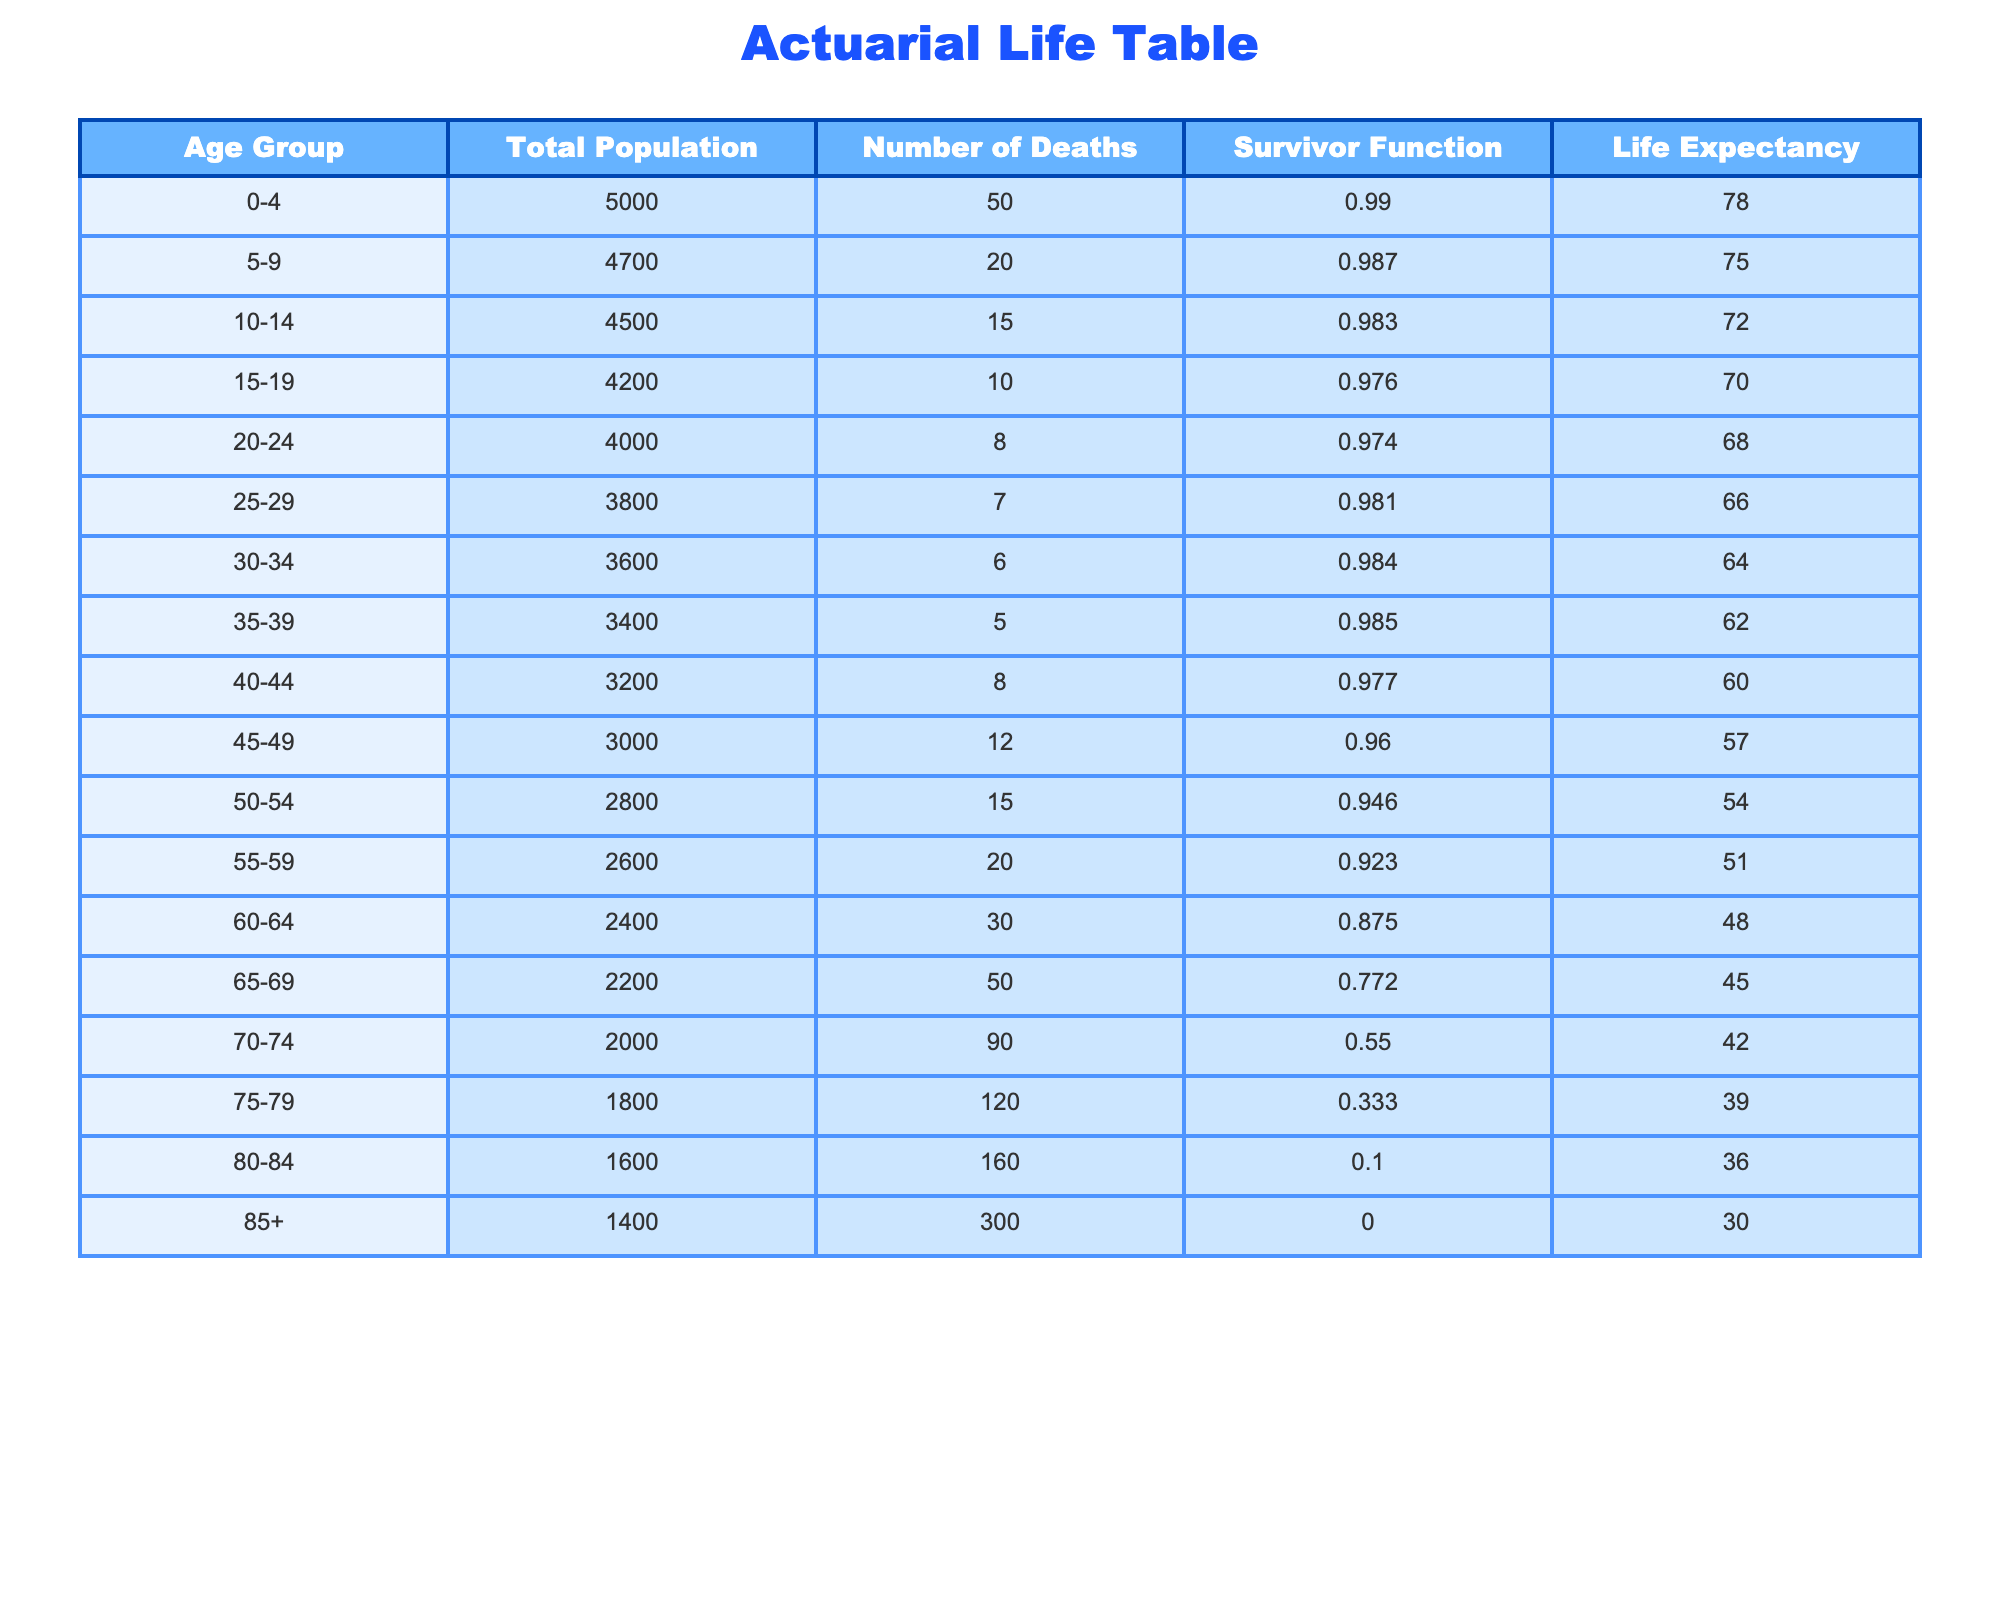What's the life expectancy of the age group 70-74? The table indicates that for the age group 70-74, the life expectancy is listed as 42 years.
Answer: 42 What is the total number of deaths in the 60-64 age group? According to the table, the number of deaths in the 60-64 age group is 30.
Answer: 30 If we combine the populations of age groups 75-79 and 80-84, what is their total population? The total population for 75-79 is 1800 and for 80-84 it is 1600. Adding these together gives 1800 + 1600 = 3400.
Answer: 3400 Is it true that more than 100 deaths occurred in the age group 85+? The table shows that there were 300 deaths in the 85+ age group, which is indeed more than 100.
Answer: Yes What is the survivor function for the age group 50-54? The survivor function for the age group 50-54 is shown in the table as 0.946.
Answer: 0.946 What age group has the highest number of deaths? Upon reviewing the table, the age group 85+ has the highest number of deaths at 300.
Answer: 85+ If we add the life expectancies of age groups 0-4, 5-9, and 10-14, what is the total? The life expectancies for these groups are 78, 75, and 72 respectively. Adding these gives 78 + 75 + 72 = 225.
Answer: 225 Is the number of deaths in the 75-79 age group greater than the number of deaths in the 70-74 age group? The table indicates that there were 120 deaths in the 75-79 group and 90 in the 70-74 group, thus, 120 is greater than 90.
Answer: Yes What is the life expectancy for the age group 45-49? From the table, the life expectancy for the age group 45-49 is 57 years.
Answer: 57 How many fewer deaths were there in the 30-34 age group compared to the 40-44 age group? The 30-34 age group had 6 deaths and the 40-44 age group had 8 deaths. The difference is 8 - 6 = 2.
Answer: 2 